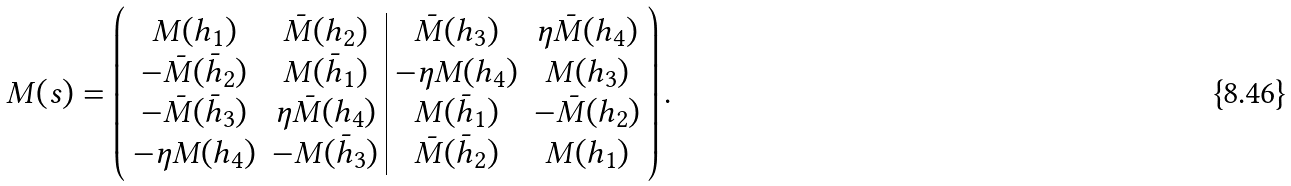<formula> <loc_0><loc_0><loc_500><loc_500>M ( s ) = \left ( \begin{array} { c c | c c } M ( h _ { 1 } ) & \bar { M } ( h _ { 2 } ) & \bar { M } ( h _ { 3 } ) & \eta \bar { M } ( h _ { 4 } ) \\ - \bar { M } ( \bar { h } _ { 2 } ) & M ( \bar { h } _ { 1 } ) & - \eta M ( h _ { 4 } ) & M ( h _ { 3 } ) \\ - \bar { M } ( \bar { h } _ { 3 } ) & \eta \bar { M } ( h _ { 4 } ) & M ( \bar { h } _ { 1 } ) & - \bar { M } ( h _ { 2 } ) \\ - \eta M ( h _ { 4 } ) & - M ( \bar { h } _ { 3 } ) & \bar { M } ( \bar { h } _ { 2 } ) & M ( h _ { 1 } ) \end{array} \right ) .</formula> 